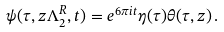<formula> <loc_0><loc_0><loc_500><loc_500>\psi ( \tau , z \Lambda ^ { R } _ { 2 } , t ) = e ^ { 6 \pi i t } \eta ( \tau ) \theta ( \tau , z ) \, .</formula> 